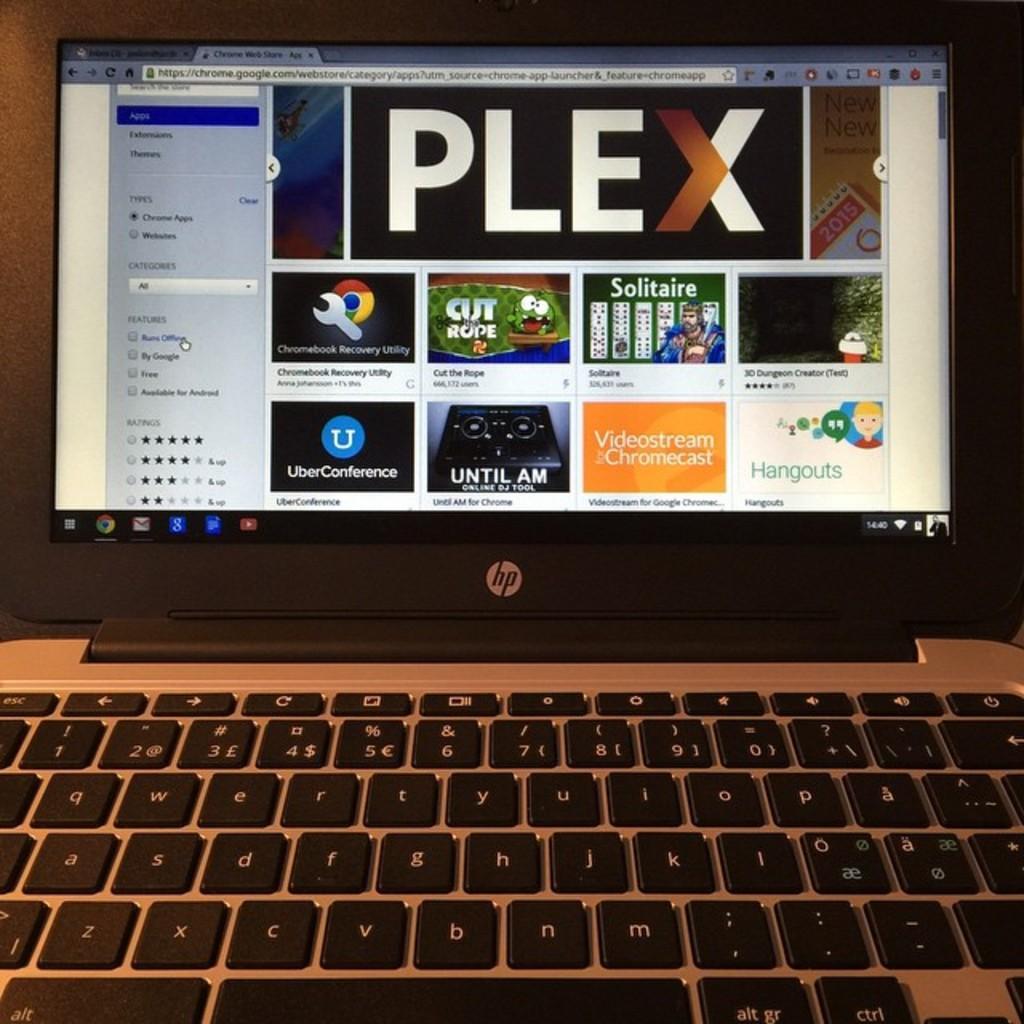How would you summarize this image in a sentence or two? It is a laptop in this there are different applications. 